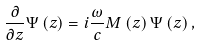Convert formula to latex. <formula><loc_0><loc_0><loc_500><loc_500>\frac { \partial } { \partial z } \Psi \left ( z \right ) = i \frac { \omega } { c } M \left ( z \right ) \Psi \left ( z \right ) ,</formula> 